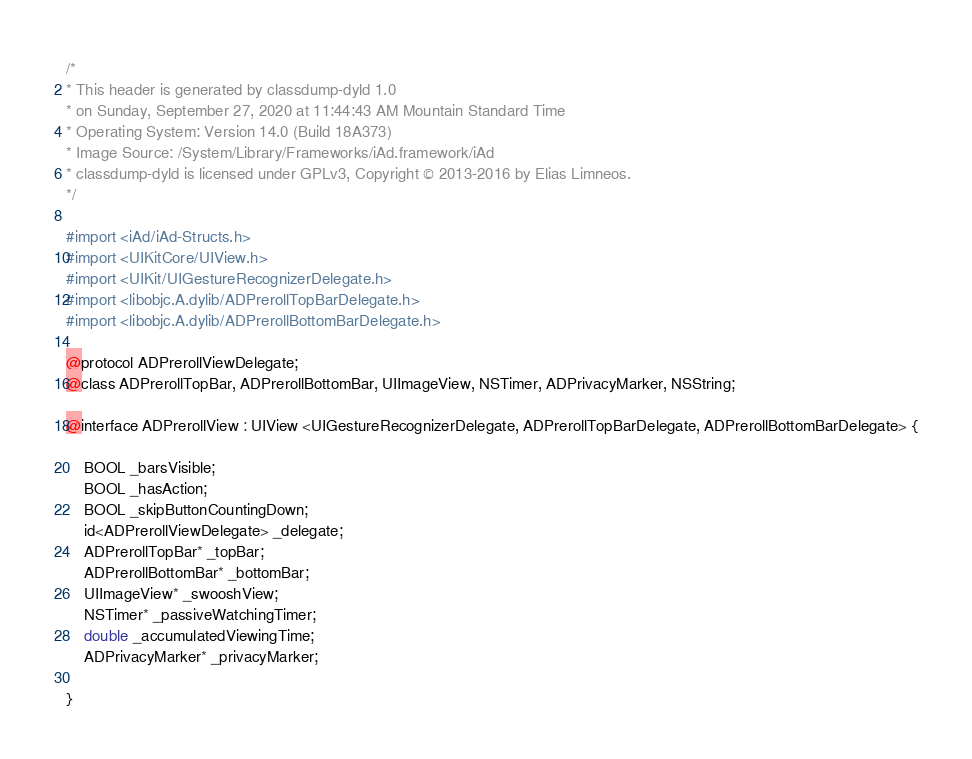Convert code to text. <code><loc_0><loc_0><loc_500><loc_500><_C_>/*
* This header is generated by classdump-dyld 1.0
* on Sunday, September 27, 2020 at 11:44:43 AM Mountain Standard Time
* Operating System: Version 14.0 (Build 18A373)
* Image Source: /System/Library/Frameworks/iAd.framework/iAd
* classdump-dyld is licensed under GPLv3, Copyright © 2013-2016 by Elias Limneos.
*/

#import <iAd/iAd-Structs.h>
#import <UIKitCore/UIView.h>
#import <UIKit/UIGestureRecognizerDelegate.h>
#import <libobjc.A.dylib/ADPrerollTopBarDelegate.h>
#import <libobjc.A.dylib/ADPrerollBottomBarDelegate.h>

@protocol ADPrerollViewDelegate;
@class ADPrerollTopBar, ADPrerollBottomBar, UIImageView, NSTimer, ADPrivacyMarker, NSString;

@interface ADPrerollView : UIView <UIGestureRecognizerDelegate, ADPrerollTopBarDelegate, ADPrerollBottomBarDelegate> {

	BOOL _barsVisible;
	BOOL _hasAction;
	BOOL _skipButtonCountingDown;
	id<ADPrerollViewDelegate> _delegate;
	ADPrerollTopBar* _topBar;
	ADPrerollBottomBar* _bottomBar;
	UIImageView* _swooshView;
	NSTimer* _passiveWatchingTimer;
	double _accumulatedViewingTime;
	ADPrivacyMarker* _privacyMarker;

}
</code> 